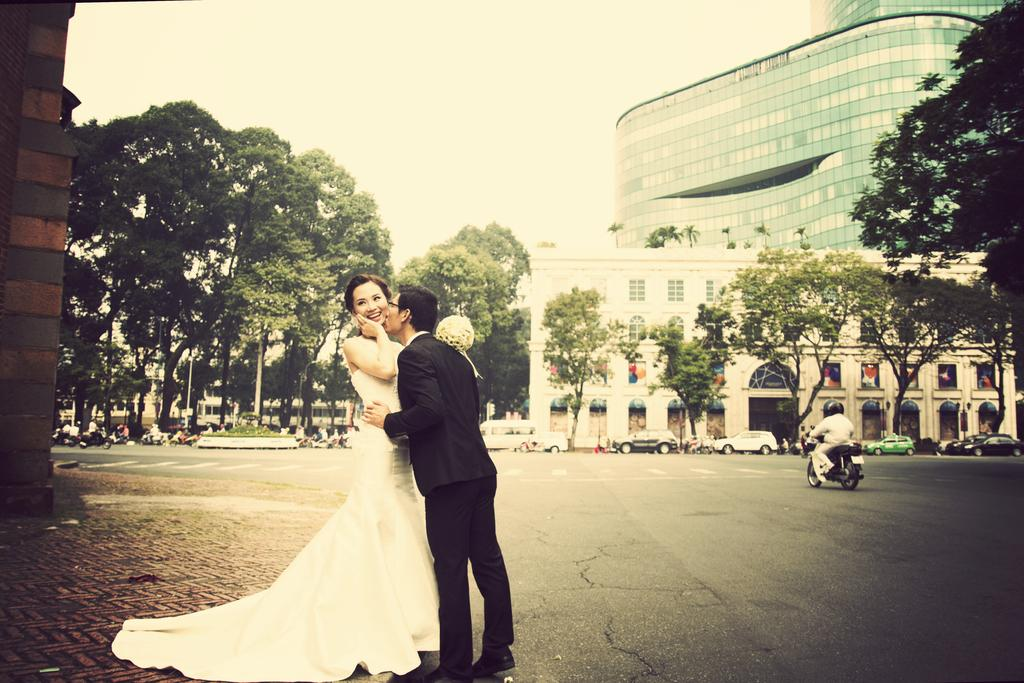Who are the main subjects in the image? A bride and bridegroom are highlighted among the people in the image. What type of surface is visible in the image? There is ground visible in the image. What can be seen in the background of the image? There are trees, buildings, and the sky visible in the image. What else is present in the image besides people? There is a road, vehicles, and trees in the image. What type of milk is being served at the wedding in the image? There is no milk present in the image, nor is there any indication of a wedding. 